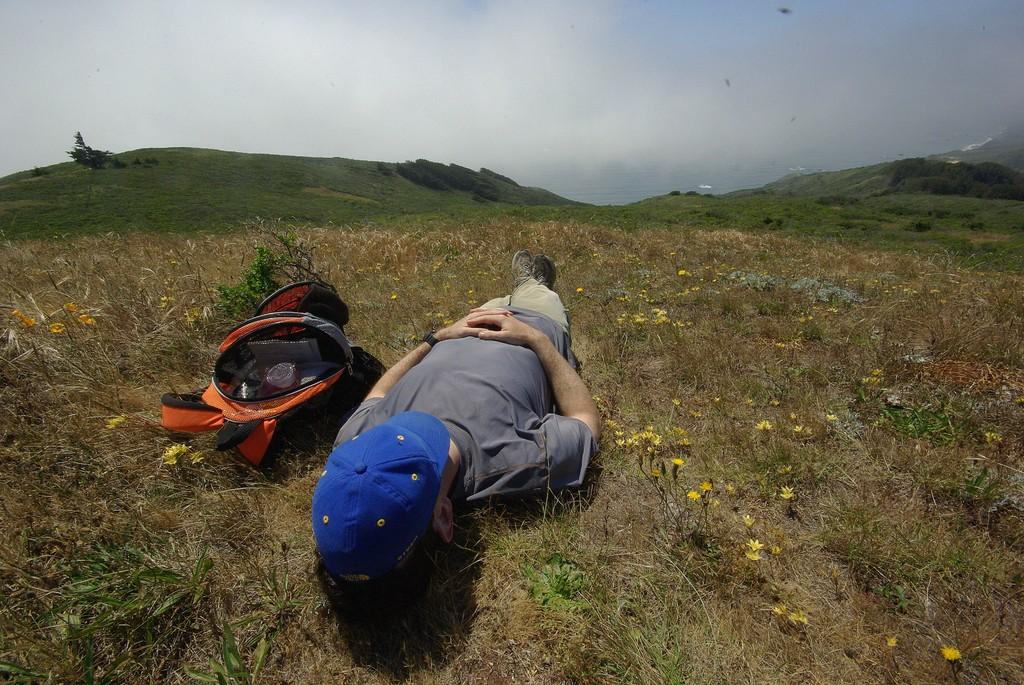What is the position of the person in the image? There is a person lying on the ground in the image. What is located beside the person? There is a bag beside the person. What can be seen in the distance in the image? Mountains are visible in the background of the image. What else is visible in the background of the image? The sky is visible in the background of the image. What type of peace treaty is being discussed in the image? There is no indication of a peace treaty or any discussion in the image; it features a person lying on the ground with a bag beside them and mountains and the sky in the background. 